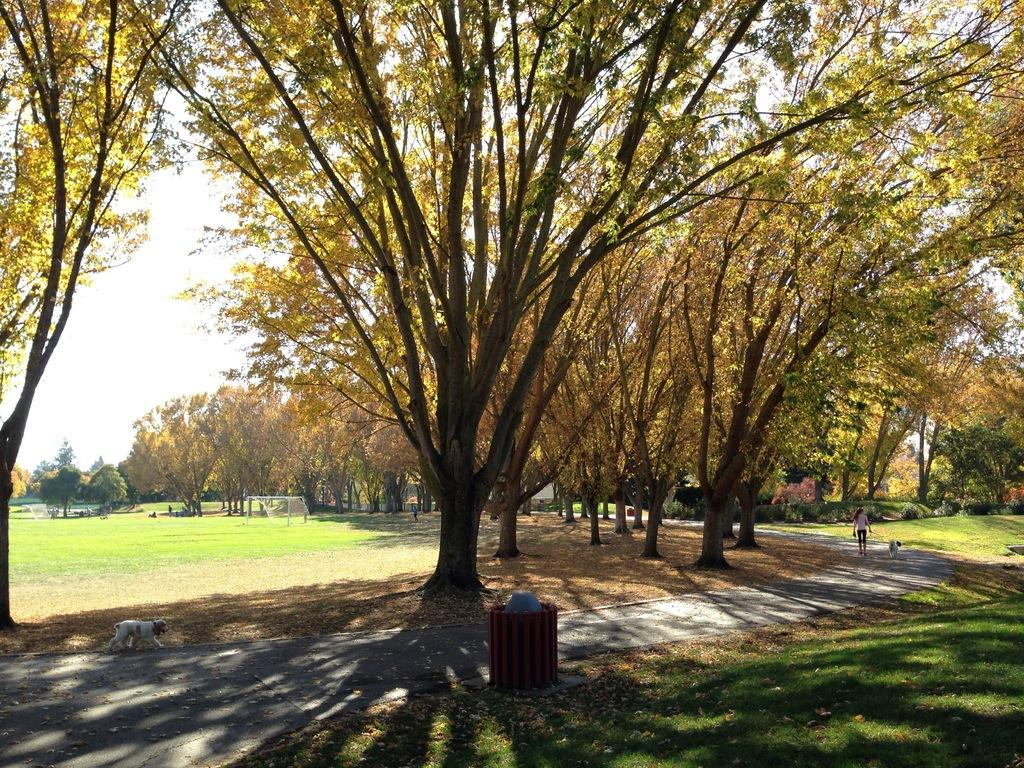What type of vegetation is present in the image? There are many trees in the image. What animals can be seen in the image? There are dogs in the image. What object is used for waste disposal in the image? There is a trash bin in the image. What is the person in the image doing? There is a person on the road in the image. What part of the natural environment is visible in the image? The sky is visible in the image. What type of ground surface is present at the bottom of the image? There is grass at the bottom of the image. What type of twig is being used to play volleyball in the image? There is no twig or volleyball present in the image. What reason does the person have for being on the road in the image? The image does not provide any information about the person's reason for being on the road. 